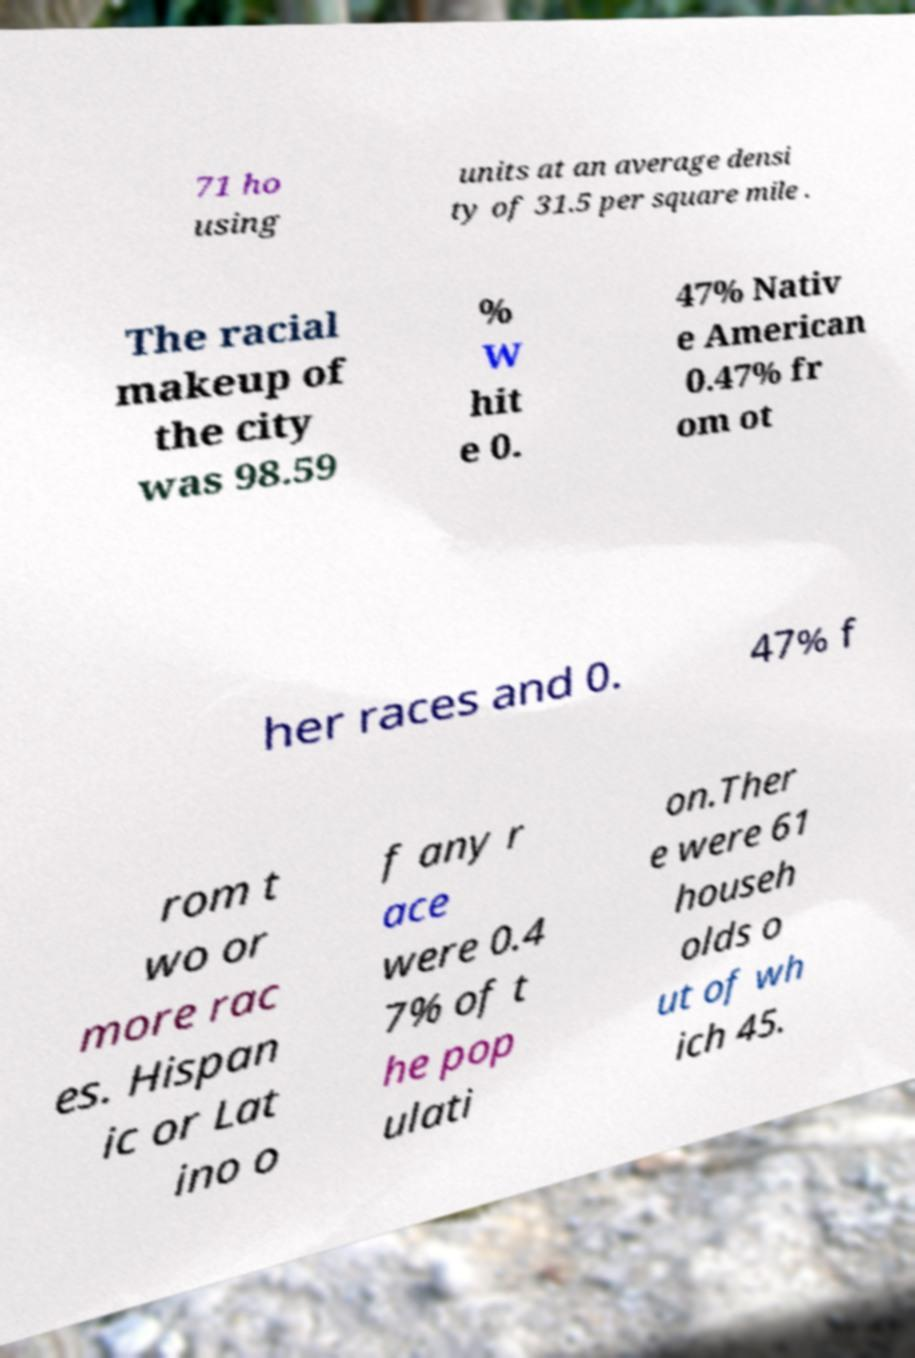Can you accurately transcribe the text from the provided image for me? 71 ho using units at an average densi ty of 31.5 per square mile . The racial makeup of the city was 98.59 % W hit e 0. 47% Nativ e American 0.47% fr om ot her races and 0. 47% f rom t wo or more rac es. Hispan ic or Lat ino o f any r ace were 0.4 7% of t he pop ulati on.Ther e were 61 househ olds o ut of wh ich 45. 